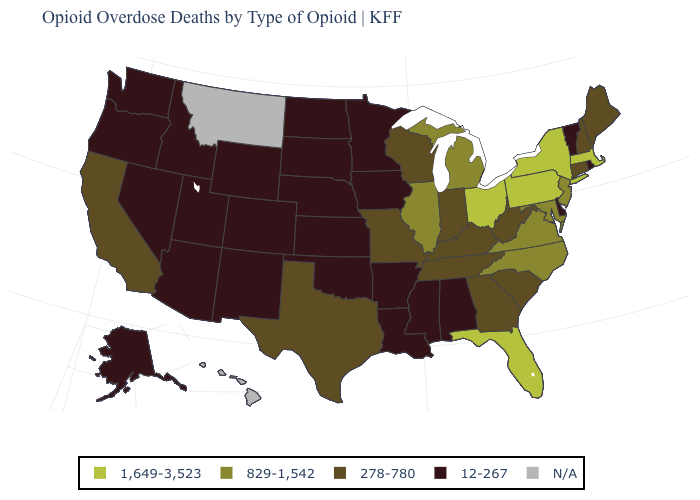Name the states that have a value in the range 12-267?
Be succinct. Alabama, Alaska, Arizona, Arkansas, Colorado, Delaware, Idaho, Iowa, Kansas, Louisiana, Minnesota, Mississippi, Nebraska, Nevada, New Mexico, North Dakota, Oklahoma, Oregon, Rhode Island, South Dakota, Utah, Vermont, Washington, Wyoming. What is the value of Missouri?
Give a very brief answer. 278-780. How many symbols are there in the legend?
Write a very short answer. 5. What is the highest value in the West ?
Quick response, please. 278-780. Among the states that border Illinois , does Kentucky have the highest value?
Quick response, please. Yes. Does New Jersey have the lowest value in the Northeast?
Concise answer only. No. Which states hav the highest value in the MidWest?
Keep it brief. Ohio. Is the legend a continuous bar?
Quick response, please. No. What is the highest value in states that border Alabama?
Write a very short answer. 1,649-3,523. Which states have the lowest value in the MidWest?
Short answer required. Iowa, Kansas, Minnesota, Nebraska, North Dakota, South Dakota. Which states have the highest value in the USA?
Answer briefly. Florida, Massachusetts, New York, Ohio, Pennsylvania. Does Oklahoma have the lowest value in the South?
Quick response, please. Yes. Which states have the lowest value in the MidWest?
Give a very brief answer. Iowa, Kansas, Minnesota, Nebraska, North Dakota, South Dakota. 